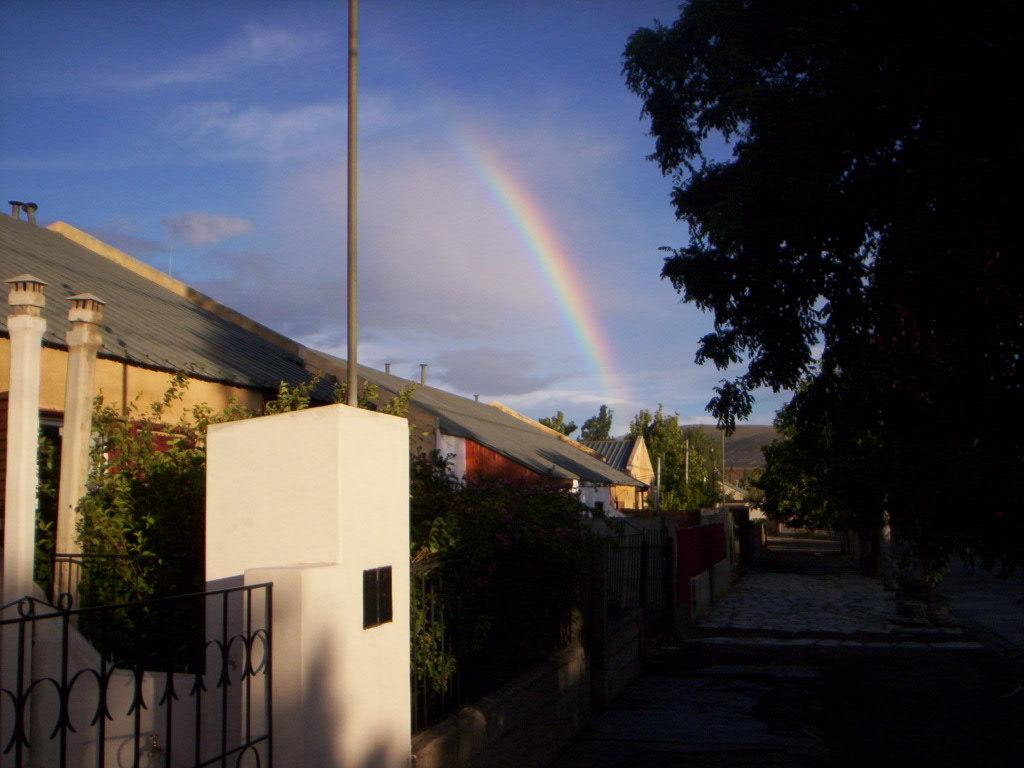What type of structures can be seen in the image? There are houses in the image. What is separating the houses from the rest of the image? There is a fence in the image. What else can be seen in the image besides the houses and fence? There are poles in the image. What type of vegetation is on the right side of the image? There are trees on the right side of the image. What is visible in the background of the image? There is a rainbow and the sky visible in the background of the image. What type of pet can be seen playing with a cow in the image? There is no pet or cow present in the image. 